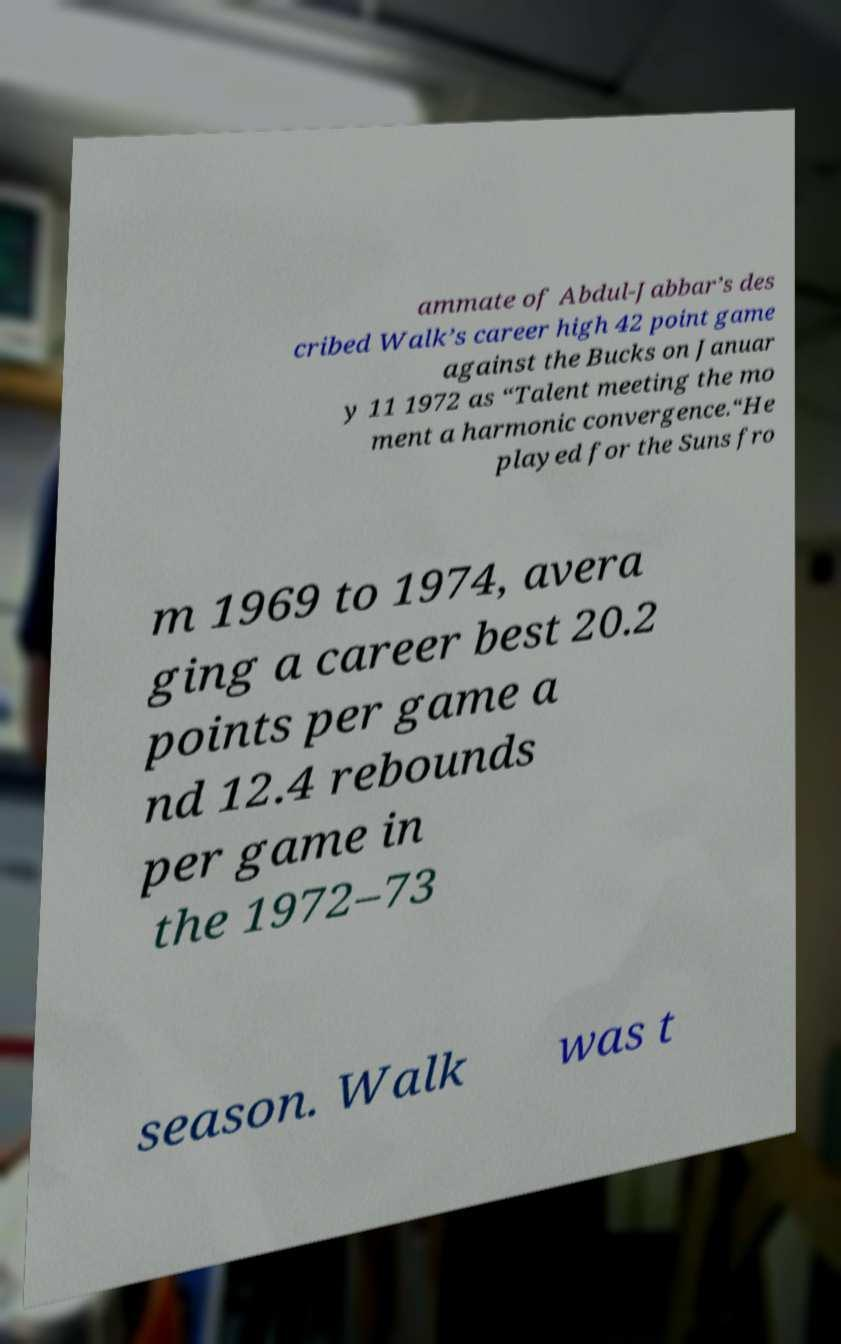I need the written content from this picture converted into text. Can you do that? ammate of Abdul-Jabbar’s des cribed Walk’s career high 42 point game against the Bucks on Januar y 11 1972 as “Talent meeting the mo ment a harmonic convergence.“He played for the Suns fro m 1969 to 1974, avera ging a career best 20.2 points per game a nd 12.4 rebounds per game in the 1972–73 season. Walk was t 